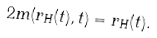<formula> <loc_0><loc_0><loc_500><loc_500>2 m ( r _ { H } ( t ) , t ) = r _ { H } ( t ) .</formula> 